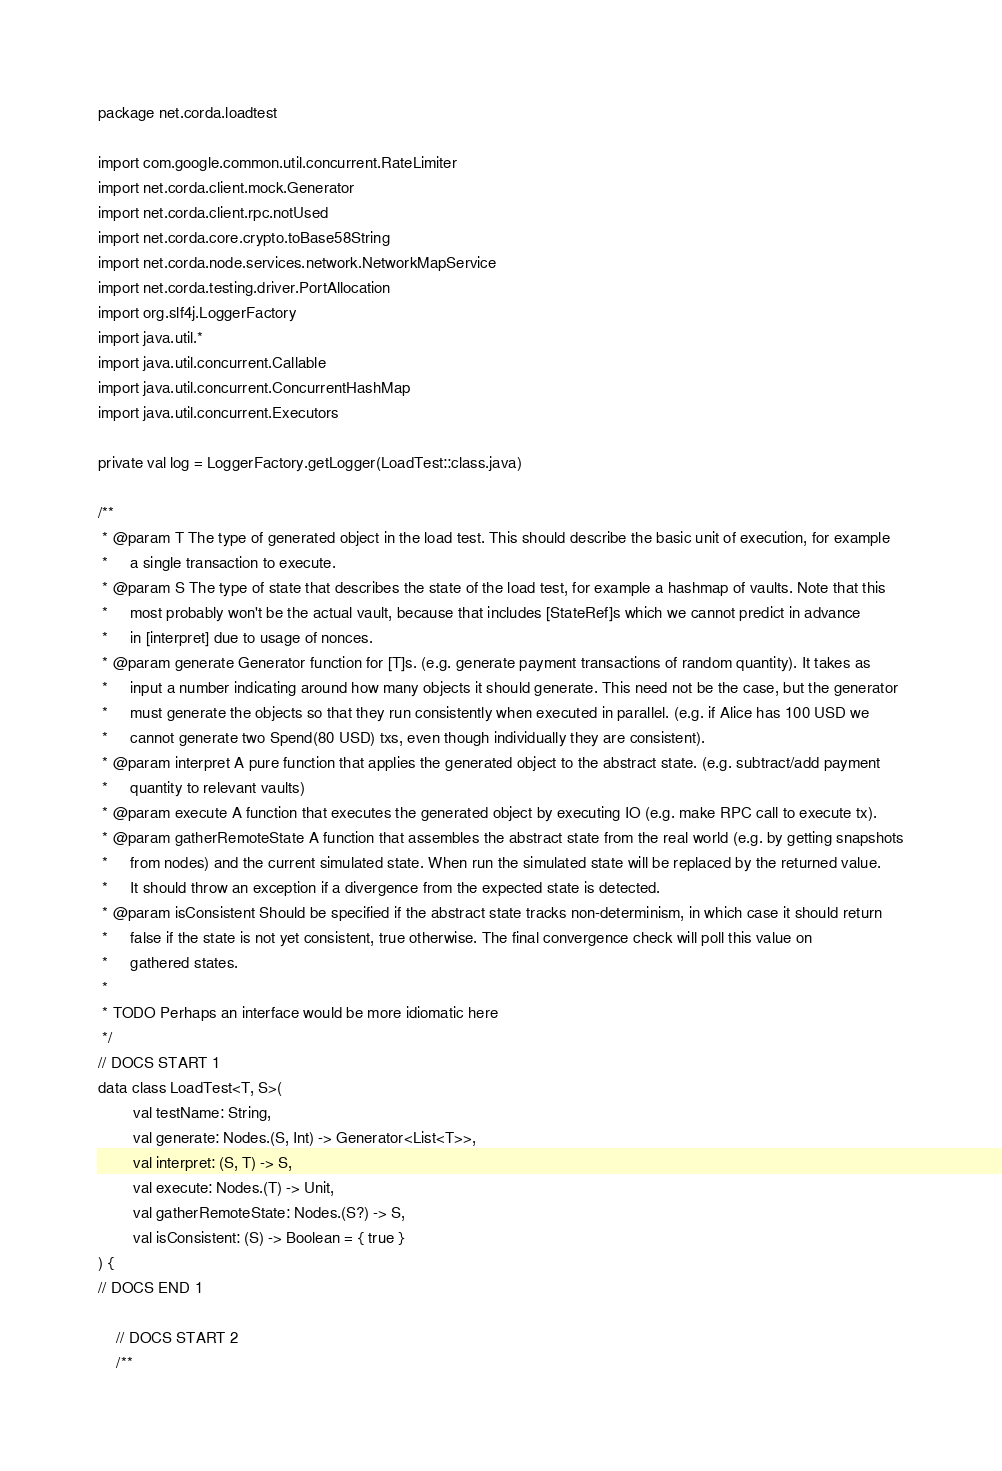Convert code to text. <code><loc_0><loc_0><loc_500><loc_500><_Kotlin_>package net.corda.loadtest

import com.google.common.util.concurrent.RateLimiter
import net.corda.client.mock.Generator
import net.corda.client.rpc.notUsed
import net.corda.core.crypto.toBase58String
import net.corda.node.services.network.NetworkMapService
import net.corda.testing.driver.PortAllocation
import org.slf4j.LoggerFactory
import java.util.*
import java.util.concurrent.Callable
import java.util.concurrent.ConcurrentHashMap
import java.util.concurrent.Executors

private val log = LoggerFactory.getLogger(LoadTest::class.java)

/**
 * @param T The type of generated object in the load test. This should describe the basic unit of execution, for example
 *     a single transaction to execute.
 * @param S The type of state that describes the state of the load test, for example a hashmap of vaults. Note that this
 *     most probably won't be the actual vault, because that includes [StateRef]s which we cannot predict in advance
 *     in [interpret] due to usage of nonces.
 * @param generate Generator function for [T]s. (e.g. generate payment transactions of random quantity). It takes as
 *     input a number indicating around how many objects it should generate. This need not be the case, but the generator
 *     must generate the objects so that they run consistently when executed in parallel. (e.g. if Alice has 100 USD we
 *     cannot generate two Spend(80 USD) txs, even though individually they are consistent).
 * @param interpret A pure function that applies the generated object to the abstract state. (e.g. subtract/add payment
 *     quantity to relevant vaults)
 * @param execute A function that executes the generated object by executing IO (e.g. make RPC call to execute tx).
 * @param gatherRemoteState A function that assembles the abstract state from the real world (e.g. by getting snapshots
 *     from nodes) and the current simulated state. When run the simulated state will be replaced by the returned value.
 *     It should throw an exception if a divergence from the expected state is detected.
 * @param isConsistent Should be specified if the abstract state tracks non-determinism, in which case it should return
 *     false if the state is not yet consistent, true otherwise. The final convergence check will poll this value on
 *     gathered states.
 *
 * TODO Perhaps an interface would be more idiomatic here
 */
// DOCS START 1
data class LoadTest<T, S>(
        val testName: String,
        val generate: Nodes.(S, Int) -> Generator<List<T>>,
        val interpret: (S, T) -> S,
        val execute: Nodes.(T) -> Unit,
        val gatherRemoteState: Nodes.(S?) -> S,
        val isConsistent: (S) -> Boolean = { true }
) {
// DOCS END 1

    // DOCS START 2
    /**</code> 